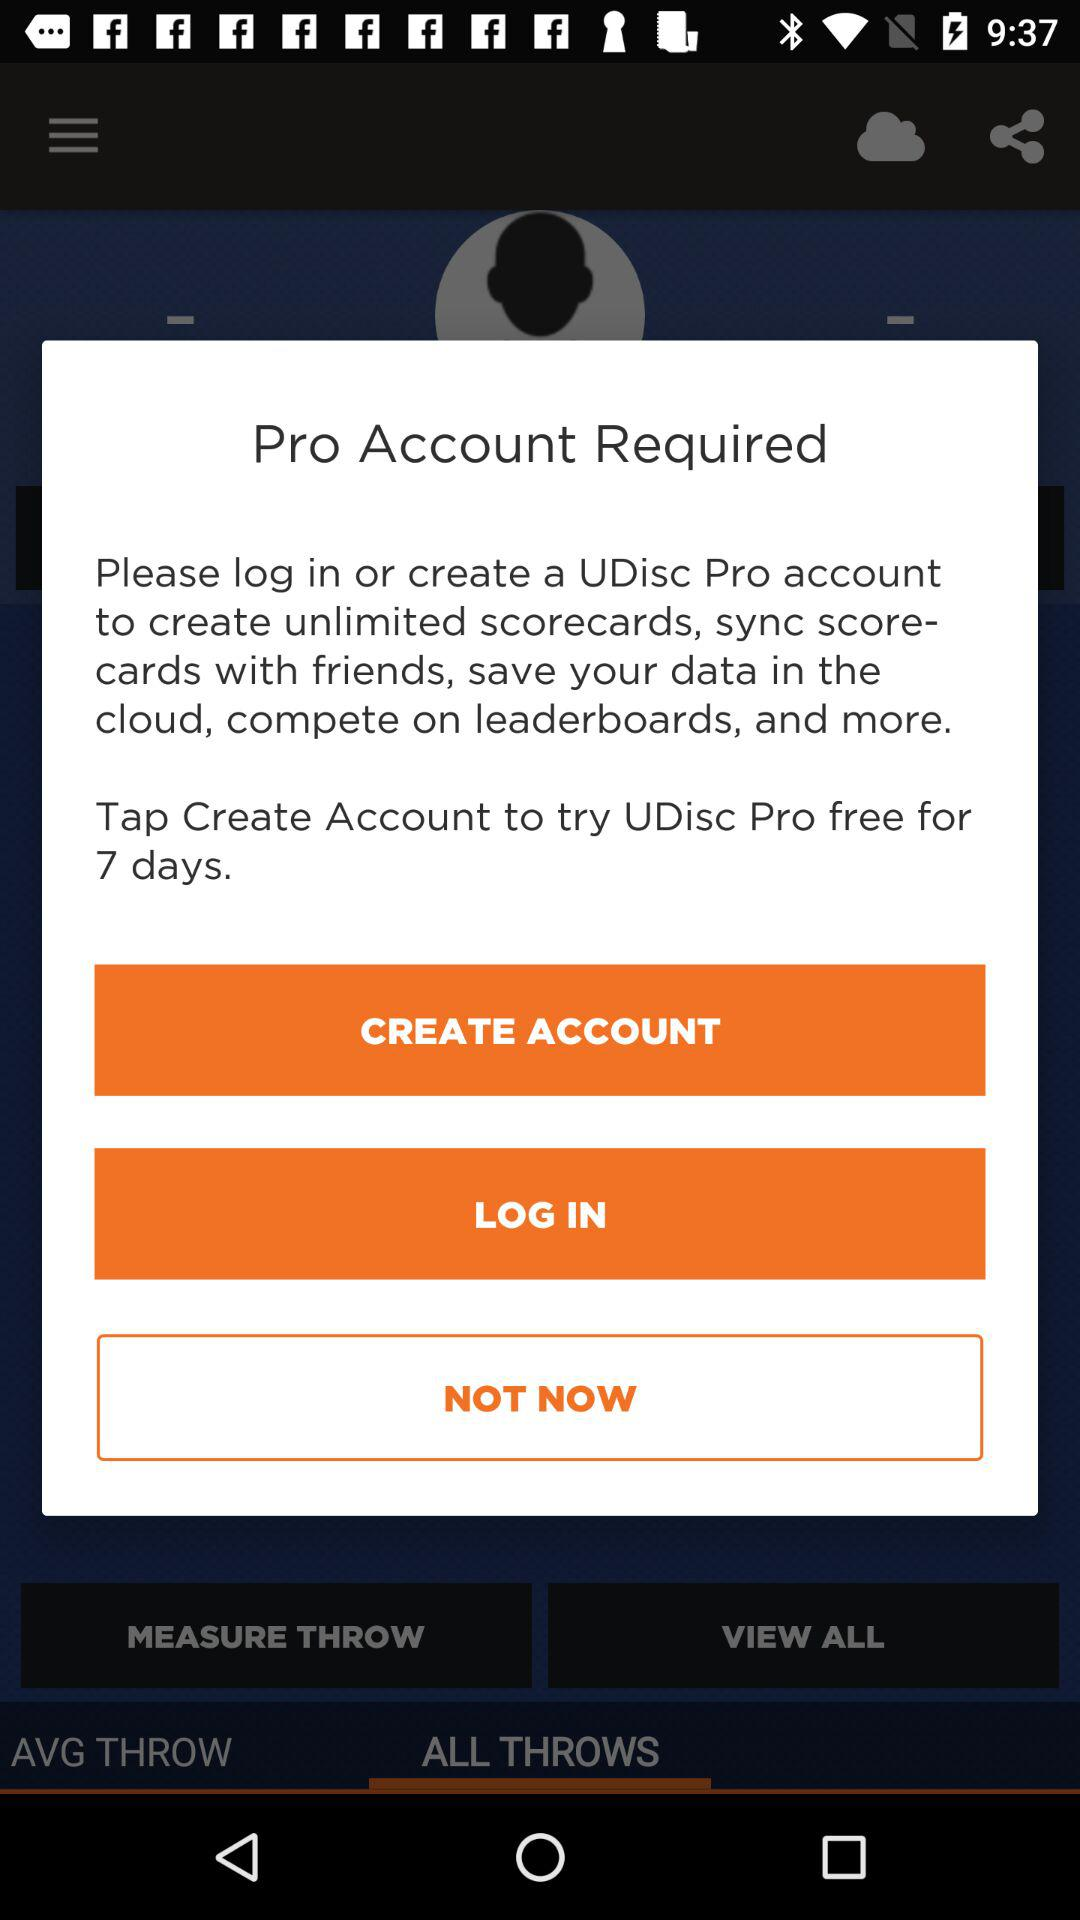In which application can we create an account? You can create an account in the application "UDisc Pro". 